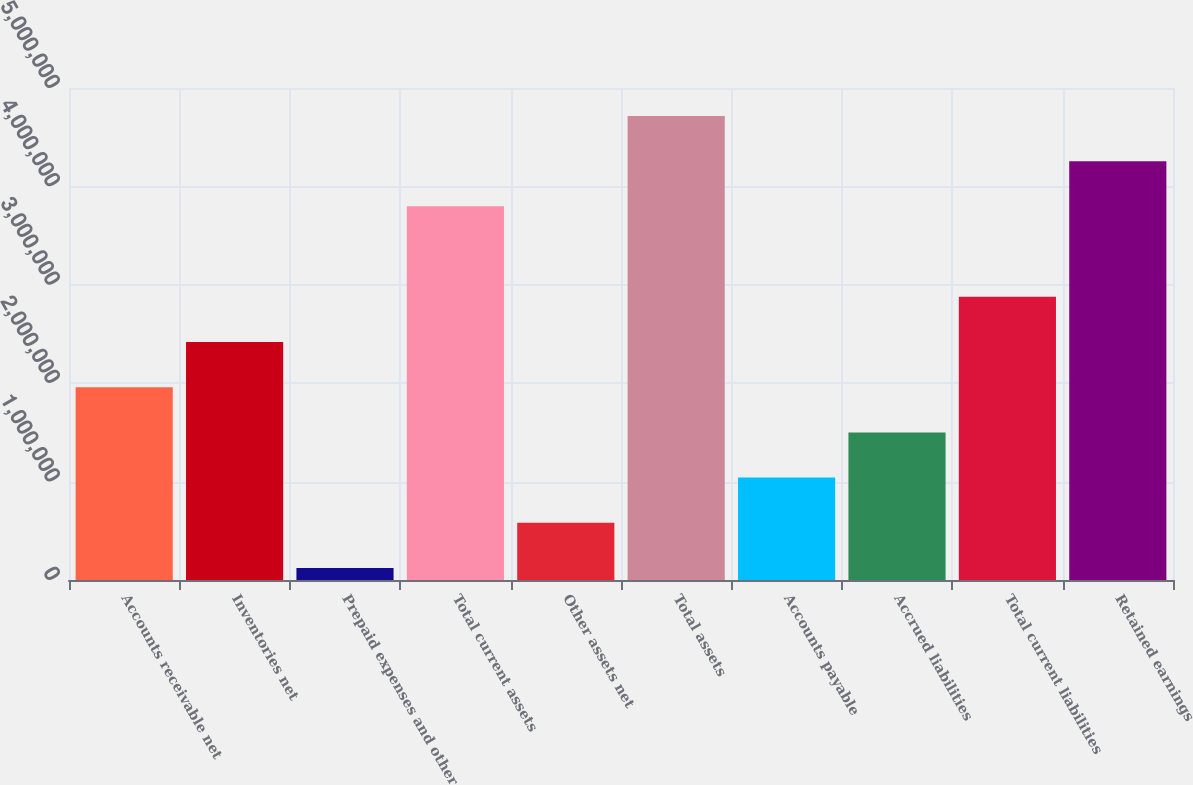Convert chart to OTSL. <chart><loc_0><loc_0><loc_500><loc_500><bar_chart><fcel>Accounts receivable net<fcel>Inventories net<fcel>Prepaid expenses and other<fcel>Total current assets<fcel>Other assets net<fcel>Total assets<fcel>Accounts payable<fcel>Accrued liabilities<fcel>Total current liabilities<fcel>Retained earnings<nl><fcel>1.95944e+06<fcel>2.41886e+06<fcel>121796<fcel>3.79709e+06<fcel>581208<fcel>4.71592e+06<fcel>1.04062e+06<fcel>1.50003e+06<fcel>2.87827e+06<fcel>4.2565e+06<nl></chart> 